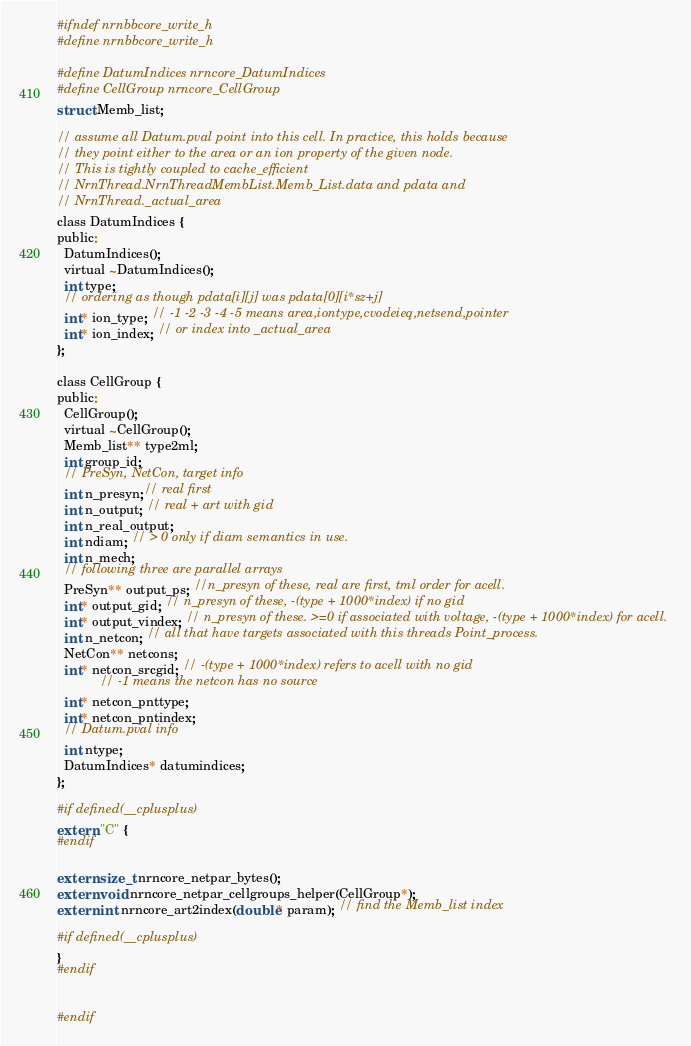<code> <loc_0><loc_0><loc_500><loc_500><_C_>#ifndef nrnbbcore_write_h
#define nrnbbcore_write_h

#define DatumIndices nrncore_DatumIndices
#define CellGroup nrncore_CellGroup
struct Memb_list;

// assume all Datum.pval point into this cell. In practice, this holds because
// they point either to the area or an ion property of the given node.
// This is tightly coupled to cache_efficient
// NrnThread.NrnThreadMembList.Memb_List.data and pdata and
// NrnThread._actual_area
class DatumIndices {
public:
  DatumIndices();
  virtual ~DatumIndices();
  int type;
  // ordering as though pdata[i][j] was pdata[0][i*sz+j]
  int* ion_type; // -1 -2 -3 -4 -5 means area,iontype,cvodeieq,netsend,pointer
  int* ion_index; // or index into _actual_area
};

class CellGroup {
public:
  CellGroup();
  virtual ~CellGroup();
  Memb_list** type2ml;
  int group_id;
  // PreSyn, NetCon, target info
  int n_presyn;// real first
  int n_output; // real + art with gid
  int n_real_output;
  int ndiam; // > 0 only if diam semantics in use.
  int n_mech;
  // following three are parallel arrays
  PreSyn** output_ps; //n_presyn of these, real are first, tml order for acell.
  int* output_gid; // n_presyn of these, -(type + 1000*index) if no gid
  int* output_vindex; // n_presyn of these. >=0 if associated with voltage, -(type + 1000*index) for acell.
  int n_netcon; // all that have targets associated with this threads Point_process.
  NetCon** netcons;
  int* netcon_srcgid; // -(type + 1000*index) refers to acell with no gid
  			// -1 means the netcon has no source
  int* netcon_pnttype;
  int* netcon_pntindex;
  // Datum.pval info
  int ntype;
  DatumIndices* datumindices;
};

#if defined(__cplusplus)
extern "C" {
#endif

extern size_t nrncore_netpar_bytes();
extern void nrncore_netpar_cellgroups_helper(CellGroup*);
extern int nrncore_art2index(double* param); // find the Memb_list index

#if defined(__cplusplus)
}
#endif


#endif
</code> 